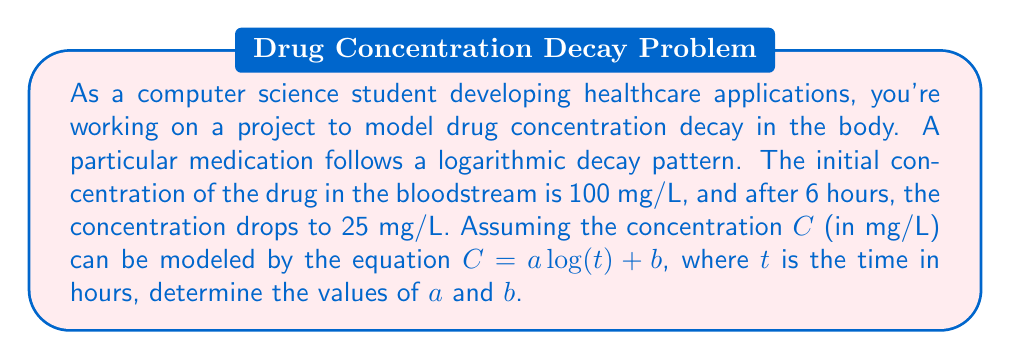What is the answer to this math problem? To solve this problem, we'll use the given information to create a system of equations and then solve for $a$ and $b$. Let's approach this step-by-step:

1) We know that at $t = 0$, $C = 100$ mg/L. However, $\log(0)$ is undefined, so we'll use the second point we know: at $t = 6$, $C = 25$ mg/L.

2) We also know that when $t = 1$, $\log(t) = 0$. At this point, $C = b$. So $b$ represents the concentration at $t = 1$ hour.

3) Let's set up our system of equations:

   $100 = a \log(1) + b$  (Equation 1)
   $25 = a \log(6) + b$   (Equation 2)

4) From Equation 1, since $\log(1) = 0$, we get:
   $100 = b$

5) Substituting this into Equation 2:
   $25 = a \log(6) + 100$

6) Rearranging:
   $a \log(6) = -75$

7) Solving for $a$:
   $a = \frac{-75}{\log(6)} \approx -54.2$

8) Therefore, our equation is:
   $C = -54.2 \log(t) + 100$

This logarithmic equation models the concentration of the drug over time, starting at 100 mg/L and decreasing as time progresses.
Answer: $a \approx -54.2$ and $b = 100$

The equation of the drug concentration over time is:
$C = -54.2 \log(t) + 100$, where $C$ is in mg/L and $t$ is in hours. 